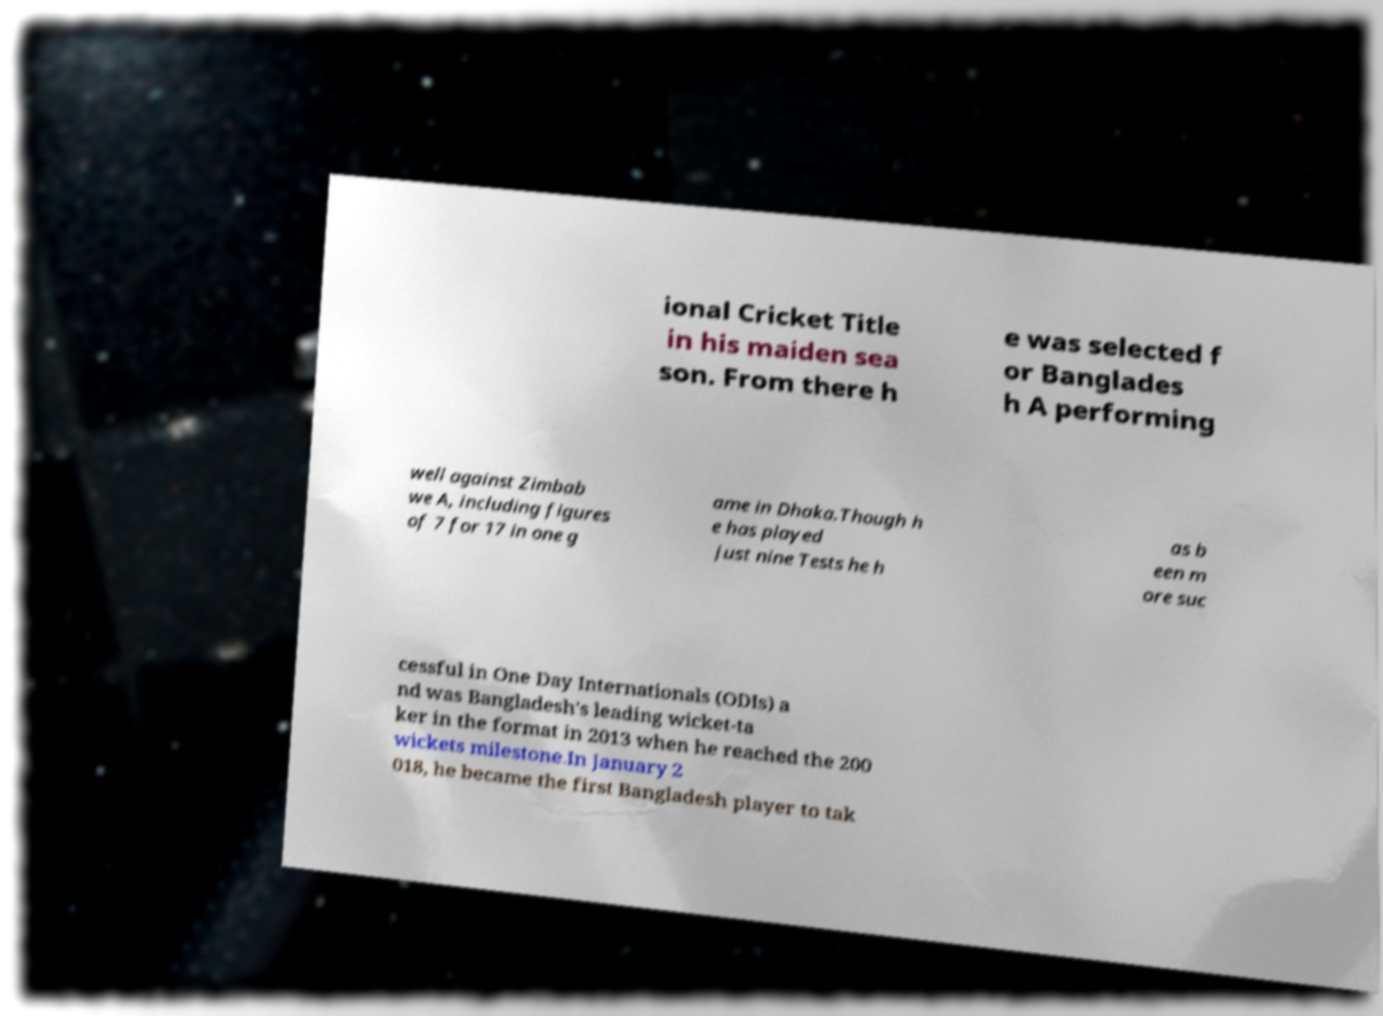Please identify and transcribe the text found in this image. ional Cricket Title in his maiden sea son. From there h e was selected f or Banglades h A performing well against Zimbab we A, including figures of 7 for 17 in one g ame in Dhaka.Though h e has played just nine Tests he h as b een m ore suc cessful in One Day Internationals (ODIs) a nd was Bangladesh's leading wicket-ta ker in the format in 2013 when he reached the 200 wickets milestone.In January 2 018, he became the first Bangladesh player to tak 